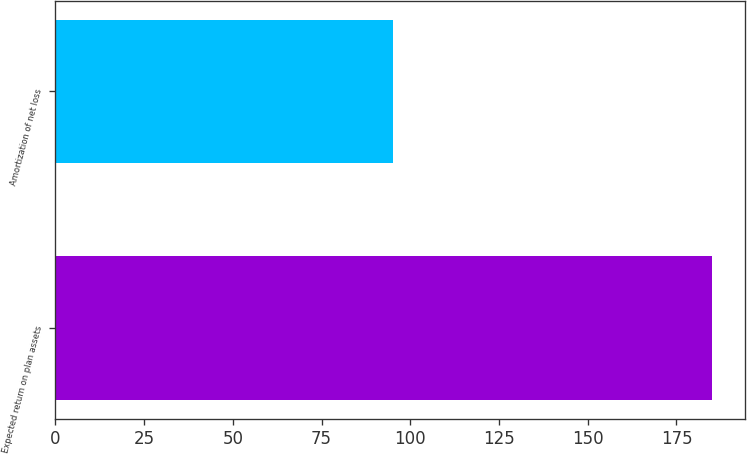<chart> <loc_0><loc_0><loc_500><loc_500><bar_chart><fcel>Expected return on plan assets<fcel>Amortization of net loss<nl><fcel>185<fcel>95<nl></chart> 